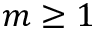<formula> <loc_0><loc_0><loc_500><loc_500>m \geq 1</formula> 